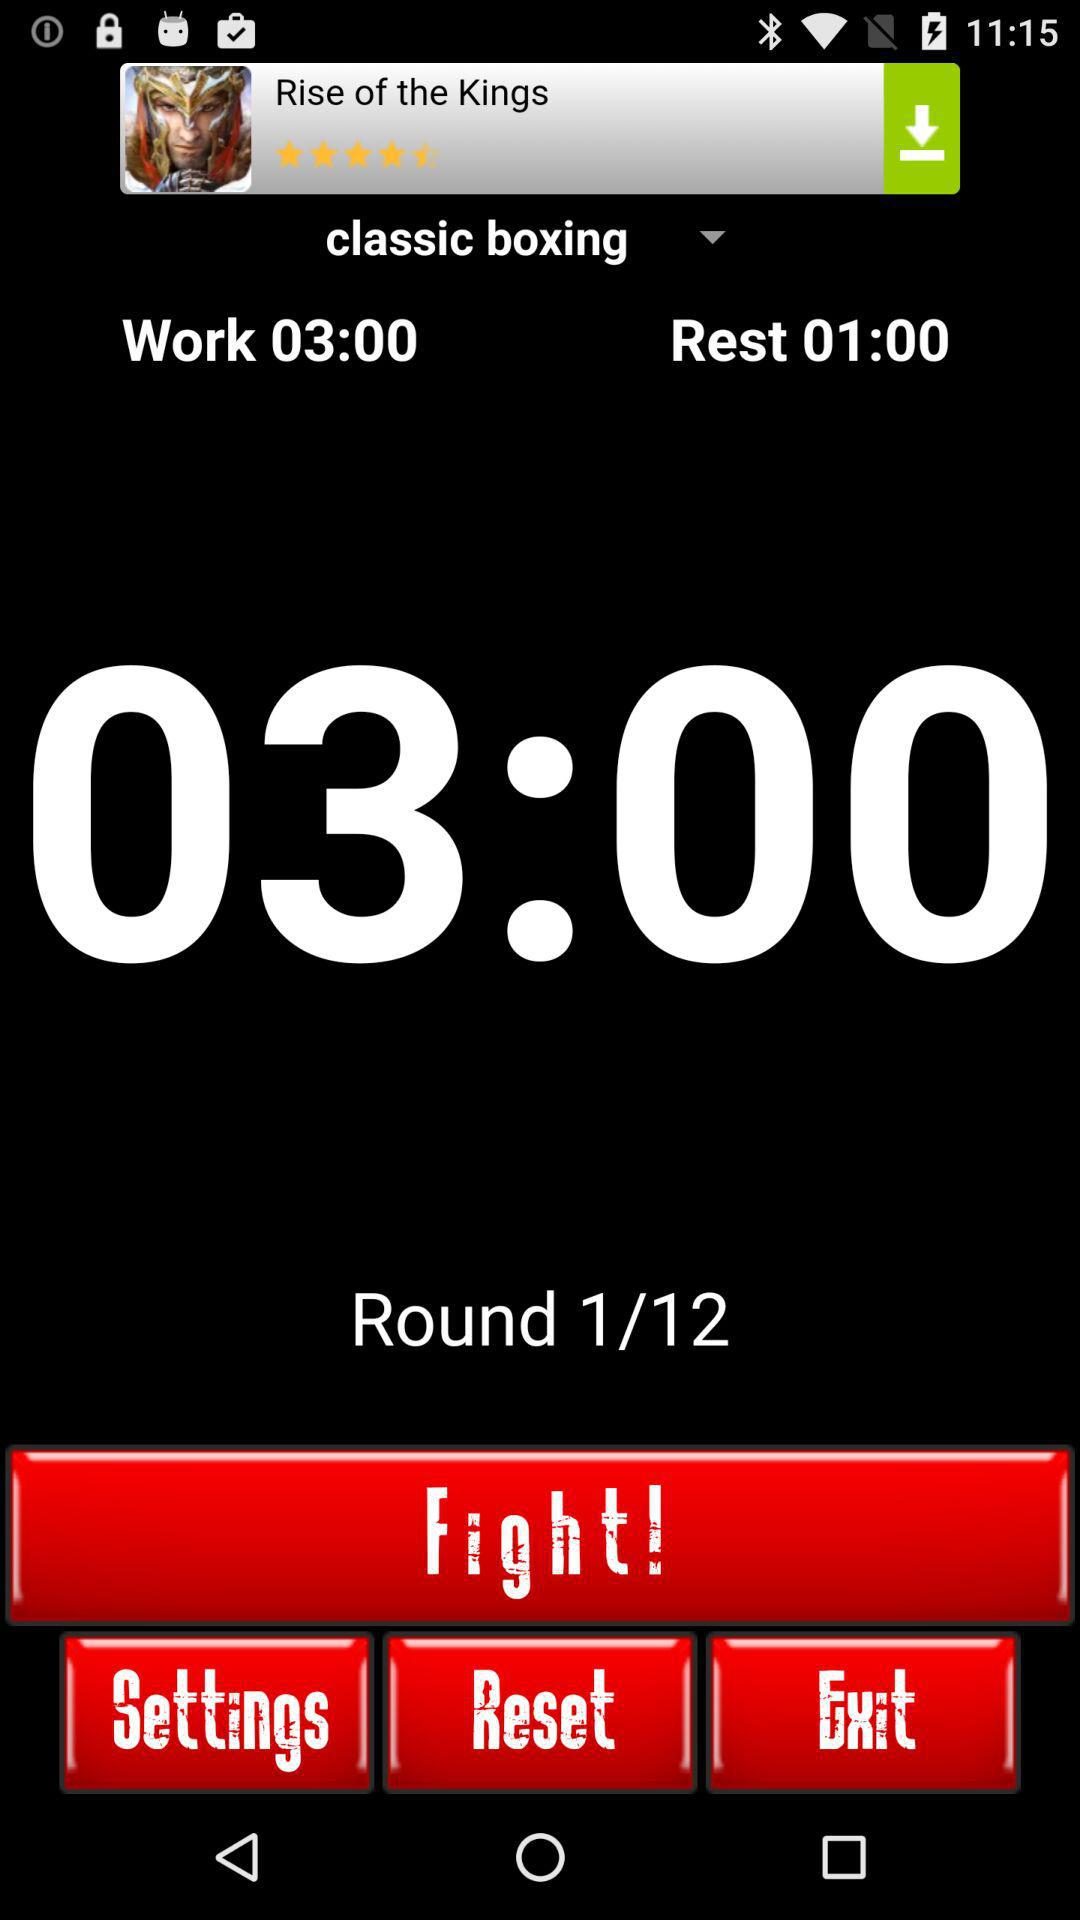What is the work duration in classic boxing? The work duration is 3 minutes. 